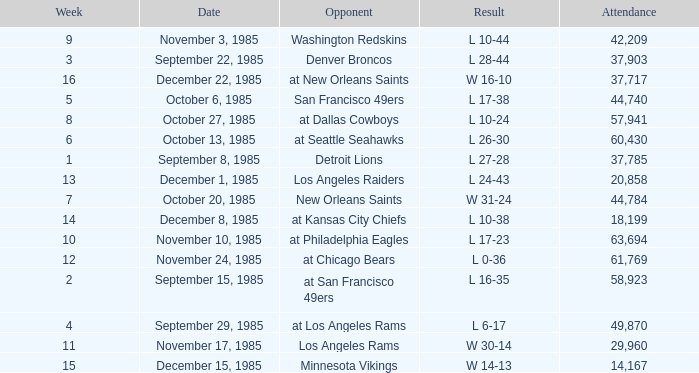Who was the opponent the falcons played against on week 3? Denver Broncos. 